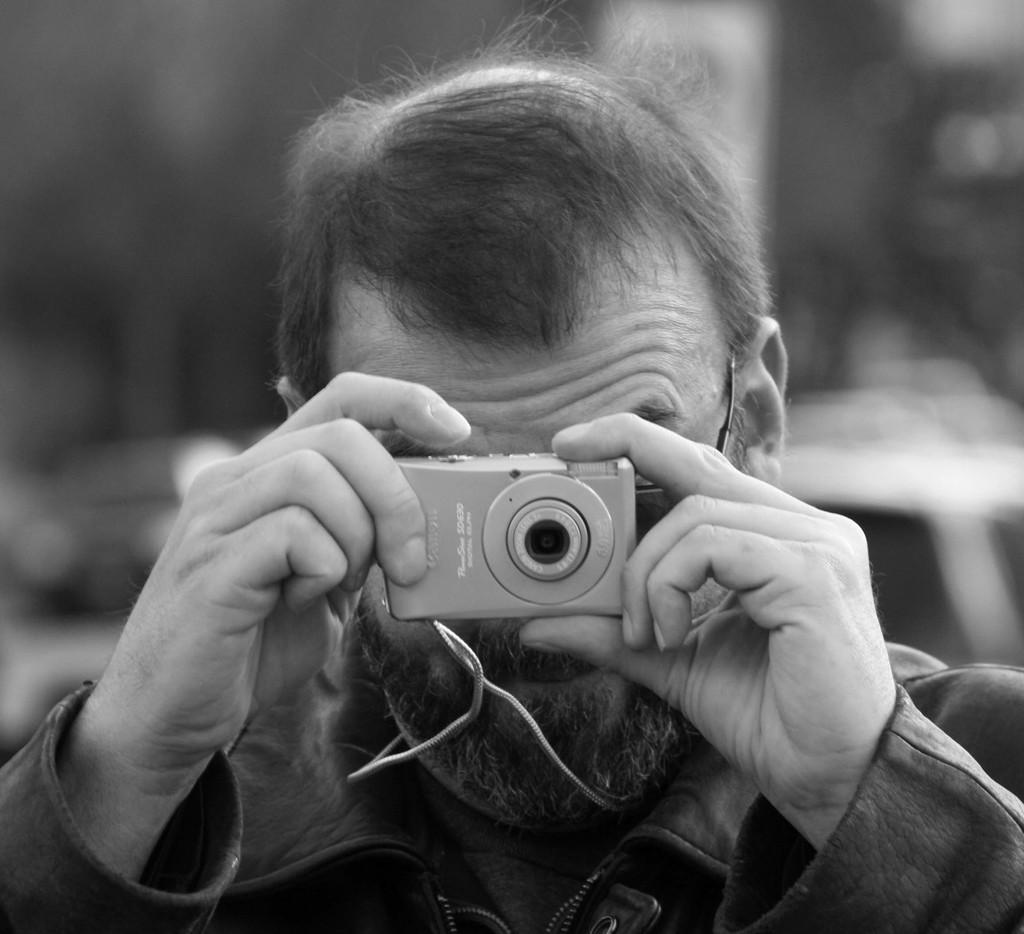Who is the main subject in the image? There is a man in the image. What is the man holding in his hand? The man is holding a camera in his hand. What is the man doing with the camera? The man is taking a picture. What can be seen in the background of the image? There are vehicles visible in the background of the image. How would you describe the background in the image? The background appears blurry. What team is the man offering to join in the image? There is no team or offer present in the image; it features a man holding a camera and taking a picture. 